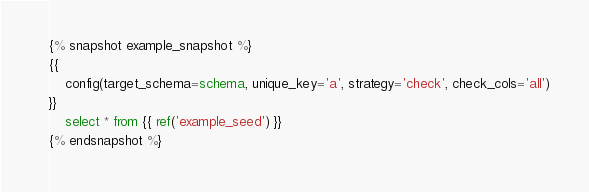<code> <loc_0><loc_0><loc_500><loc_500><_SQL_>{% snapshot example_snapshot %}
{{
	config(target_schema=schema, unique_key='a', strategy='check', check_cols='all')
}}
	select * from {{ ref('example_seed') }}
{% endsnapshot %}
</code> 